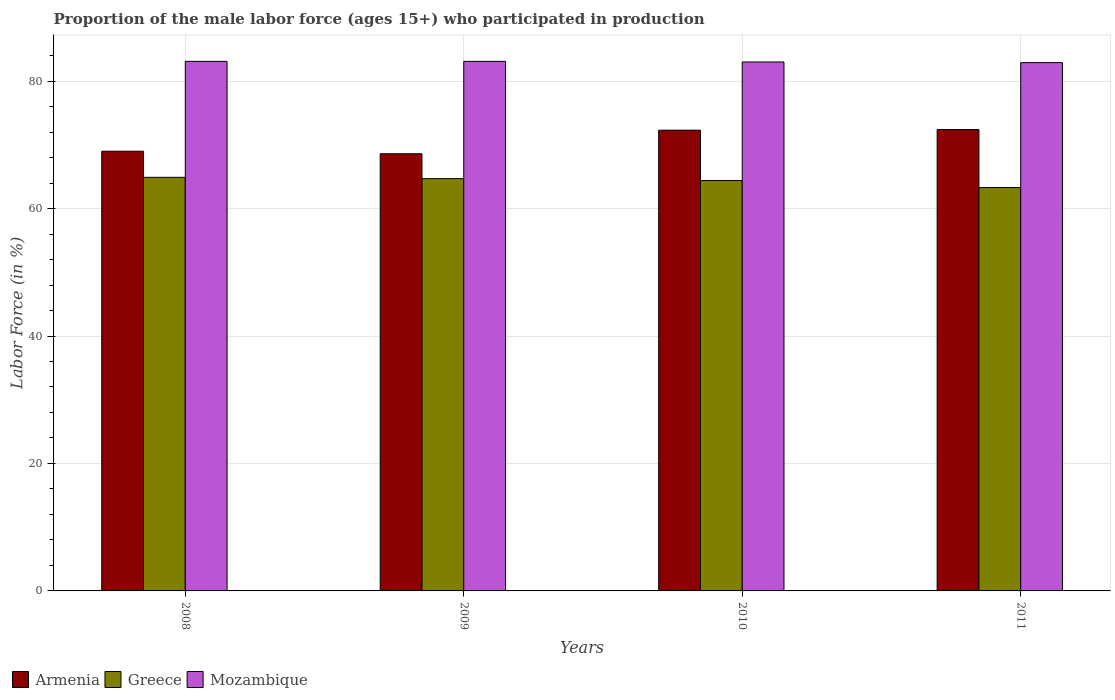How many different coloured bars are there?
Provide a succinct answer. 3. How many groups of bars are there?
Your answer should be very brief. 4. Are the number of bars per tick equal to the number of legend labels?
Provide a short and direct response. Yes. Are the number of bars on each tick of the X-axis equal?
Offer a terse response. Yes. How many bars are there on the 4th tick from the right?
Your answer should be very brief. 3. In how many cases, is the number of bars for a given year not equal to the number of legend labels?
Make the answer very short. 0. What is the proportion of the male labor force who participated in production in Mozambique in 2008?
Your answer should be compact. 83.1. Across all years, what is the maximum proportion of the male labor force who participated in production in Mozambique?
Offer a very short reply. 83.1. Across all years, what is the minimum proportion of the male labor force who participated in production in Mozambique?
Your answer should be very brief. 82.9. In which year was the proportion of the male labor force who participated in production in Greece maximum?
Ensure brevity in your answer.  2008. In which year was the proportion of the male labor force who participated in production in Armenia minimum?
Keep it short and to the point. 2009. What is the total proportion of the male labor force who participated in production in Mozambique in the graph?
Keep it short and to the point. 332.1. What is the difference between the proportion of the male labor force who participated in production in Armenia in 2009 and that in 2010?
Give a very brief answer. -3.7. What is the difference between the proportion of the male labor force who participated in production in Greece in 2010 and the proportion of the male labor force who participated in production in Armenia in 2009?
Offer a terse response. -4.2. What is the average proportion of the male labor force who participated in production in Mozambique per year?
Ensure brevity in your answer.  83.02. In the year 2010, what is the difference between the proportion of the male labor force who participated in production in Greece and proportion of the male labor force who participated in production in Mozambique?
Provide a short and direct response. -18.6. What is the ratio of the proportion of the male labor force who participated in production in Mozambique in 2008 to that in 2010?
Ensure brevity in your answer.  1. Is the proportion of the male labor force who participated in production in Armenia in 2009 less than that in 2010?
Give a very brief answer. Yes. Is the difference between the proportion of the male labor force who participated in production in Greece in 2008 and 2011 greater than the difference between the proportion of the male labor force who participated in production in Mozambique in 2008 and 2011?
Your response must be concise. Yes. What is the difference between the highest and the second highest proportion of the male labor force who participated in production in Armenia?
Provide a succinct answer. 0.1. What is the difference between the highest and the lowest proportion of the male labor force who participated in production in Greece?
Your answer should be very brief. 1.6. In how many years, is the proportion of the male labor force who participated in production in Mozambique greater than the average proportion of the male labor force who participated in production in Mozambique taken over all years?
Your answer should be compact. 2. Is the sum of the proportion of the male labor force who participated in production in Greece in 2008 and 2009 greater than the maximum proportion of the male labor force who participated in production in Mozambique across all years?
Provide a short and direct response. Yes. What does the 2nd bar from the left in 2008 represents?
Give a very brief answer. Greece. What does the 1st bar from the right in 2010 represents?
Keep it short and to the point. Mozambique. How many bars are there?
Your response must be concise. 12. Are all the bars in the graph horizontal?
Keep it short and to the point. No. What is the difference between two consecutive major ticks on the Y-axis?
Offer a very short reply. 20. Are the values on the major ticks of Y-axis written in scientific E-notation?
Offer a very short reply. No. Does the graph contain any zero values?
Your response must be concise. No. How many legend labels are there?
Provide a short and direct response. 3. How are the legend labels stacked?
Your answer should be compact. Horizontal. What is the title of the graph?
Offer a terse response. Proportion of the male labor force (ages 15+) who participated in production. What is the Labor Force (in %) in Greece in 2008?
Your answer should be very brief. 64.9. What is the Labor Force (in %) of Mozambique in 2008?
Offer a terse response. 83.1. What is the Labor Force (in %) of Armenia in 2009?
Your answer should be very brief. 68.6. What is the Labor Force (in %) of Greece in 2009?
Provide a succinct answer. 64.7. What is the Labor Force (in %) of Mozambique in 2009?
Your answer should be very brief. 83.1. What is the Labor Force (in %) of Armenia in 2010?
Offer a terse response. 72.3. What is the Labor Force (in %) of Greece in 2010?
Your answer should be compact. 64.4. What is the Labor Force (in %) in Armenia in 2011?
Provide a short and direct response. 72.4. What is the Labor Force (in %) in Greece in 2011?
Ensure brevity in your answer.  63.3. What is the Labor Force (in %) in Mozambique in 2011?
Provide a succinct answer. 82.9. Across all years, what is the maximum Labor Force (in %) of Armenia?
Make the answer very short. 72.4. Across all years, what is the maximum Labor Force (in %) of Greece?
Provide a short and direct response. 64.9. Across all years, what is the maximum Labor Force (in %) of Mozambique?
Keep it short and to the point. 83.1. Across all years, what is the minimum Labor Force (in %) in Armenia?
Your response must be concise. 68.6. Across all years, what is the minimum Labor Force (in %) in Greece?
Keep it short and to the point. 63.3. Across all years, what is the minimum Labor Force (in %) of Mozambique?
Give a very brief answer. 82.9. What is the total Labor Force (in %) in Armenia in the graph?
Make the answer very short. 282.3. What is the total Labor Force (in %) in Greece in the graph?
Your answer should be compact. 257.3. What is the total Labor Force (in %) of Mozambique in the graph?
Ensure brevity in your answer.  332.1. What is the difference between the Labor Force (in %) of Armenia in 2008 and that in 2010?
Offer a terse response. -3.3. What is the difference between the Labor Force (in %) of Greece in 2008 and that in 2010?
Provide a short and direct response. 0.5. What is the difference between the Labor Force (in %) in Mozambique in 2008 and that in 2011?
Your response must be concise. 0.2. What is the difference between the Labor Force (in %) of Armenia in 2009 and that in 2010?
Your response must be concise. -3.7. What is the difference between the Labor Force (in %) in Armenia in 2009 and that in 2011?
Provide a short and direct response. -3.8. What is the difference between the Labor Force (in %) in Mozambique in 2009 and that in 2011?
Provide a succinct answer. 0.2. What is the difference between the Labor Force (in %) in Armenia in 2010 and that in 2011?
Provide a short and direct response. -0.1. What is the difference between the Labor Force (in %) of Armenia in 2008 and the Labor Force (in %) of Greece in 2009?
Offer a very short reply. 4.3. What is the difference between the Labor Force (in %) of Armenia in 2008 and the Labor Force (in %) of Mozambique in 2009?
Provide a succinct answer. -14.1. What is the difference between the Labor Force (in %) in Greece in 2008 and the Labor Force (in %) in Mozambique in 2009?
Your answer should be very brief. -18.2. What is the difference between the Labor Force (in %) of Armenia in 2008 and the Labor Force (in %) of Mozambique in 2010?
Keep it short and to the point. -14. What is the difference between the Labor Force (in %) of Greece in 2008 and the Labor Force (in %) of Mozambique in 2010?
Offer a very short reply. -18.1. What is the difference between the Labor Force (in %) of Armenia in 2008 and the Labor Force (in %) of Greece in 2011?
Keep it short and to the point. 5.7. What is the difference between the Labor Force (in %) of Armenia in 2009 and the Labor Force (in %) of Greece in 2010?
Your answer should be compact. 4.2. What is the difference between the Labor Force (in %) in Armenia in 2009 and the Labor Force (in %) in Mozambique in 2010?
Keep it short and to the point. -14.4. What is the difference between the Labor Force (in %) in Greece in 2009 and the Labor Force (in %) in Mozambique in 2010?
Provide a succinct answer. -18.3. What is the difference between the Labor Force (in %) in Armenia in 2009 and the Labor Force (in %) in Mozambique in 2011?
Provide a succinct answer. -14.3. What is the difference between the Labor Force (in %) in Greece in 2009 and the Labor Force (in %) in Mozambique in 2011?
Your answer should be very brief. -18.2. What is the difference between the Labor Force (in %) in Greece in 2010 and the Labor Force (in %) in Mozambique in 2011?
Make the answer very short. -18.5. What is the average Labor Force (in %) of Armenia per year?
Your answer should be compact. 70.58. What is the average Labor Force (in %) in Greece per year?
Provide a succinct answer. 64.33. What is the average Labor Force (in %) in Mozambique per year?
Your answer should be very brief. 83.03. In the year 2008, what is the difference between the Labor Force (in %) of Armenia and Labor Force (in %) of Mozambique?
Give a very brief answer. -14.1. In the year 2008, what is the difference between the Labor Force (in %) of Greece and Labor Force (in %) of Mozambique?
Offer a very short reply. -18.2. In the year 2009, what is the difference between the Labor Force (in %) of Armenia and Labor Force (in %) of Greece?
Your answer should be very brief. 3.9. In the year 2009, what is the difference between the Labor Force (in %) of Greece and Labor Force (in %) of Mozambique?
Ensure brevity in your answer.  -18.4. In the year 2010, what is the difference between the Labor Force (in %) of Armenia and Labor Force (in %) of Mozambique?
Provide a succinct answer. -10.7. In the year 2010, what is the difference between the Labor Force (in %) in Greece and Labor Force (in %) in Mozambique?
Provide a succinct answer. -18.6. In the year 2011, what is the difference between the Labor Force (in %) in Armenia and Labor Force (in %) in Greece?
Offer a terse response. 9.1. In the year 2011, what is the difference between the Labor Force (in %) of Armenia and Labor Force (in %) of Mozambique?
Offer a very short reply. -10.5. In the year 2011, what is the difference between the Labor Force (in %) of Greece and Labor Force (in %) of Mozambique?
Give a very brief answer. -19.6. What is the ratio of the Labor Force (in %) in Armenia in 2008 to that in 2010?
Your answer should be compact. 0.95. What is the ratio of the Labor Force (in %) of Armenia in 2008 to that in 2011?
Your answer should be compact. 0.95. What is the ratio of the Labor Force (in %) of Greece in 2008 to that in 2011?
Make the answer very short. 1.03. What is the ratio of the Labor Force (in %) in Armenia in 2009 to that in 2010?
Provide a succinct answer. 0.95. What is the ratio of the Labor Force (in %) in Mozambique in 2009 to that in 2010?
Your answer should be compact. 1. What is the ratio of the Labor Force (in %) in Armenia in 2009 to that in 2011?
Your response must be concise. 0.95. What is the ratio of the Labor Force (in %) of Greece in 2009 to that in 2011?
Your answer should be very brief. 1.02. What is the ratio of the Labor Force (in %) of Mozambique in 2009 to that in 2011?
Keep it short and to the point. 1. What is the ratio of the Labor Force (in %) in Greece in 2010 to that in 2011?
Give a very brief answer. 1.02. What is the difference between the highest and the second highest Labor Force (in %) in Armenia?
Your answer should be very brief. 0.1. 